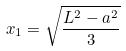Convert formula to latex. <formula><loc_0><loc_0><loc_500><loc_500>x _ { 1 } = \sqrt { \frac { L ^ { 2 } - a ^ { 2 } } { 3 } }</formula> 